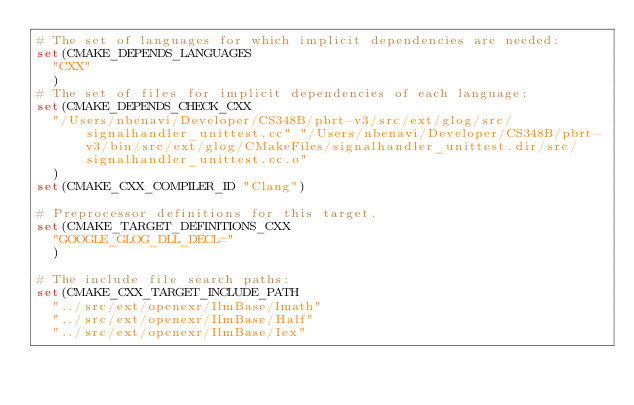<code> <loc_0><loc_0><loc_500><loc_500><_CMake_># The set of languages for which implicit dependencies are needed:
set(CMAKE_DEPENDS_LANGUAGES
  "CXX"
  )
# The set of files for implicit dependencies of each language:
set(CMAKE_DEPENDS_CHECK_CXX
  "/Users/nbenavi/Developer/CS348B/pbrt-v3/src/ext/glog/src/signalhandler_unittest.cc" "/Users/nbenavi/Developer/CS348B/pbrt-v3/bin/src/ext/glog/CMakeFiles/signalhandler_unittest.dir/src/signalhandler_unittest.cc.o"
  )
set(CMAKE_CXX_COMPILER_ID "Clang")

# Preprocessor definitions for this target.
set(CMAKE_TARGET_DEFINITIONS_CXX
  "GOOGLE_GLOG_DLL_DECL="
  )

# The include file search paths:
set(CMAKE_CXX_TARGET_INCLUDE_PATH
  "../src/ext/openexr/IlmBase/Imath"
  "../src/ext/openexr/IlmBase/Half"
  "../src/ext/openexr/IlmBase/Iex"</code> 